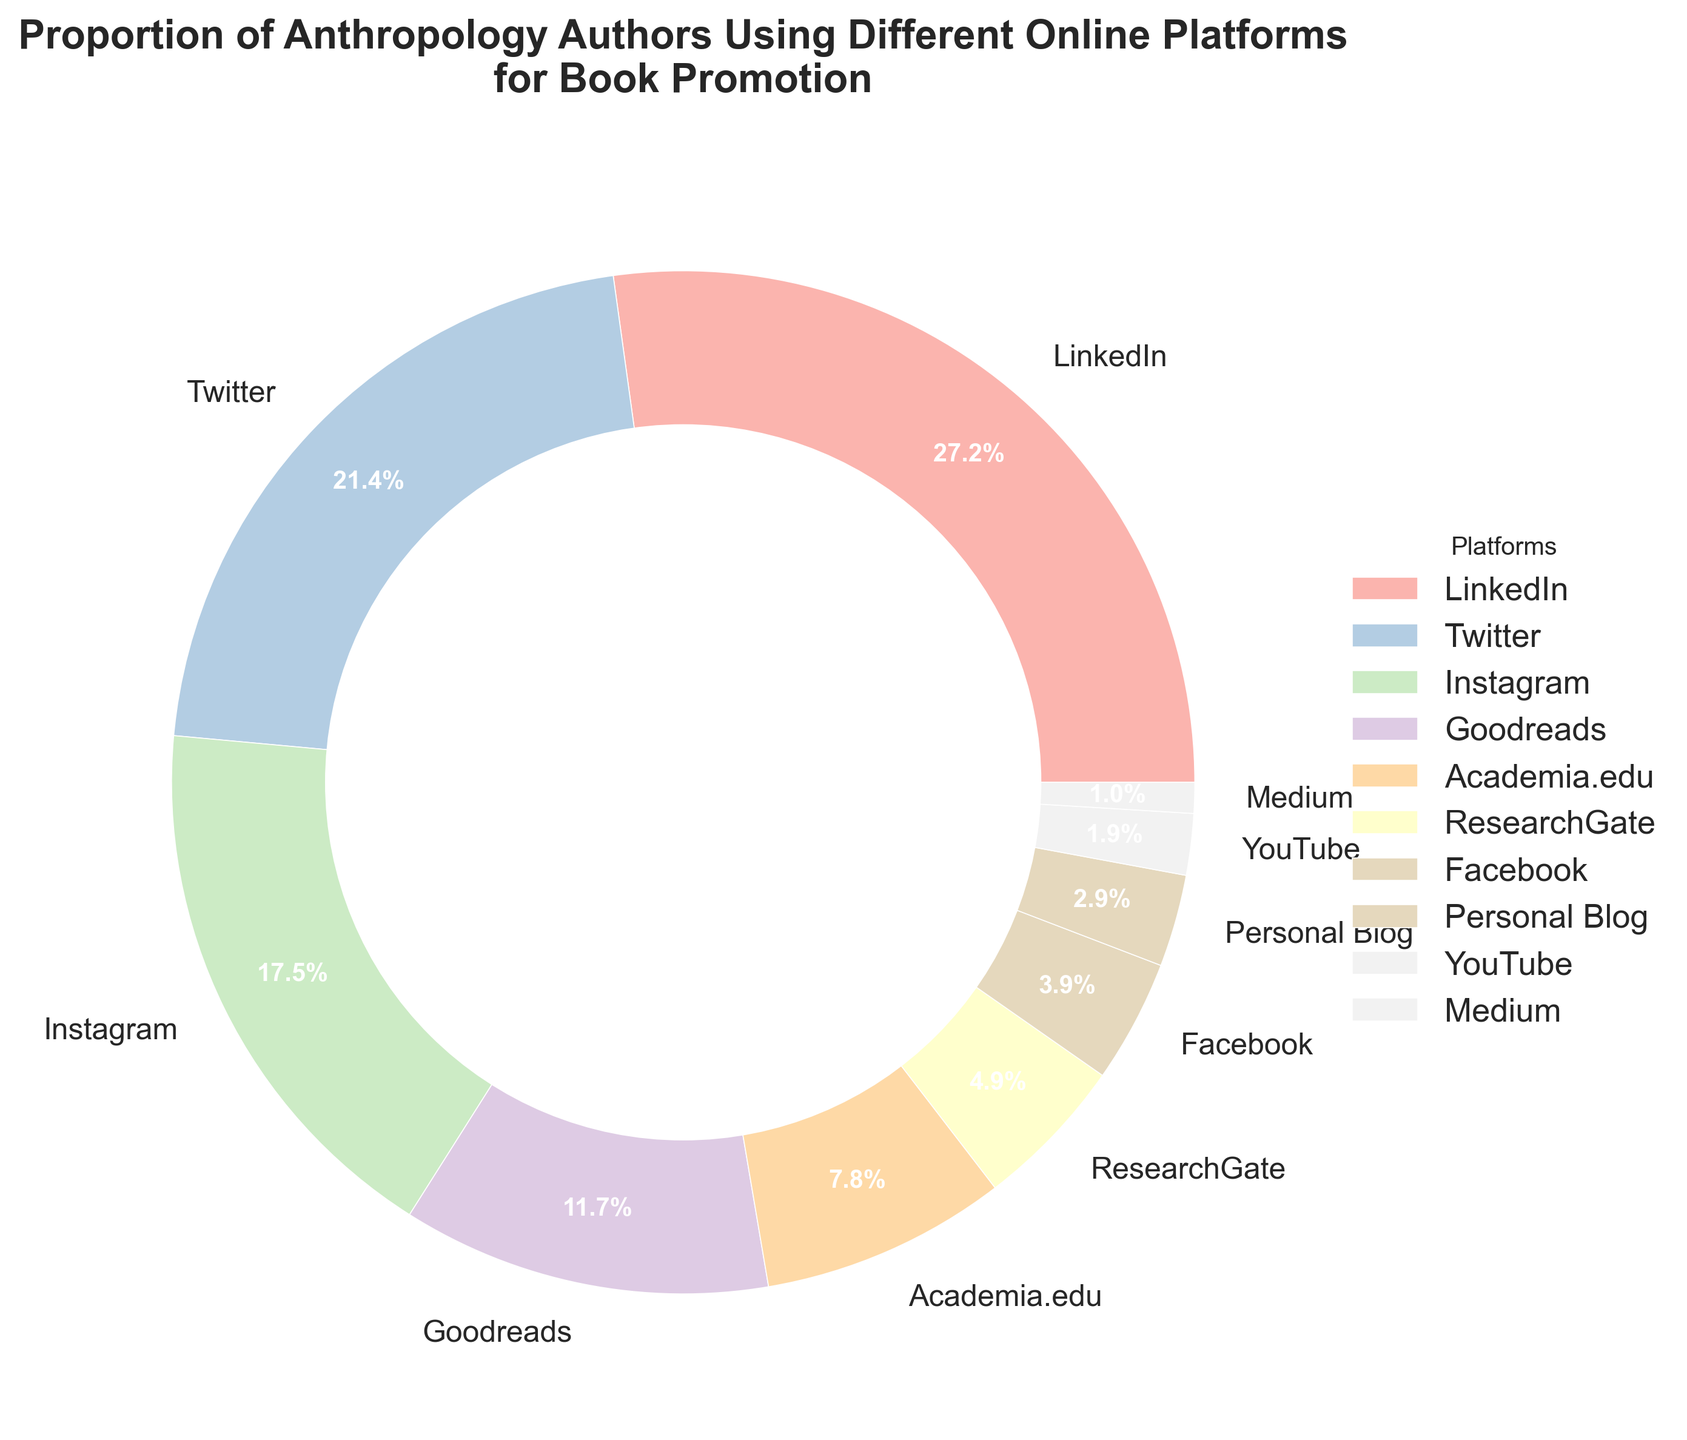What is the least used online platform for book promotion among anthropology authors? To find the least used platform, look at the platform with the smallest percentage. The percentage for Medium is 1%, which is the smallest value.
Answer: Medium Which online platform has almost three times fewer users for book promotion compared to LinkedIn? First, find the percentage for LinkedIn, which is 28%. Three times fewer users would be approximately 28 / 3 = 9.33%. ResearchGate has 5%, which is the closest option but less than 9.33%.
Answer: ResearchGate How many more authors are using LinkedIn compared to Facebook for book promotion? The percentage of authors using LinkedIn is 28%, and the percentage for Facebook is 4%. The difference is 28% - 4% = 24%.
Answer: 24% Which two platforms combined have the highest proportion of anthropology authors using them for book promotion? Look for the platforms with the two highest percentages. LinkedIn has 28% and Twitter has 22%. Adding them up: 28% + 22% = 50%.
Answer: LinkedIn and Twitter Are there more authors using Instagram or Goodreads for book promotion, and by how much? Instagram has 18% and Goodreads has 12%. The difference is 18% - 12% = 6%.
Answer: Instagram by 6% What percentage of authors use either ResearchGate or Personal Blog for book promotion? ResearchGate has 5% and Personal Blog has 3%. Adding them together: 5% + 3% = 8%.
Answer: 8% Which platform is used by twice as many authors for book promotion compared to Academia.edu? The percentage for Academia.edu is 8%. Double this percentage is 8% * 2 = 16%. Instagram has 18%, which is close to 16% but slightly more.
Answer: Instagram How many platforms have more than 10% of anthropology authors using them for book promotion? Look at the data and count the platforms with percentages greater than 10%. LinkedIn (28%), Twitter (22%), and Instagram (18%), Goodreads (12%) – total is 4 platforms.
Answer: 4 What is the total percentage of authors using Facebook, Personal Blog, YouTube, and Medium combined? Add the percentages for these platforms: Facebook (4%), Personal Blog (3%), YouTube (2%), and Medium (1%). 4% + 3% + 2% + 1% = 10%.
Answer: 10% Which two platforms combined have a smaller percentage of users than Twitter alone? Twitter has 22%. Look for two platforms with a combined percentage smaller than 22%. Academia.edu (8%) and ResearchGate (5%) combined give 8% + 5% = 13%. Adding Facebook (4%) gives 13% + 4% = 17%. Thus, Facebook (4%) and YouTube (2%) combined give 4% + 2% = 6%, which is even smaller than 22%.
Answer: Any two from Academia.edu, ResearchGate, Facebook, Personal Blog, YouTube, and Medium 